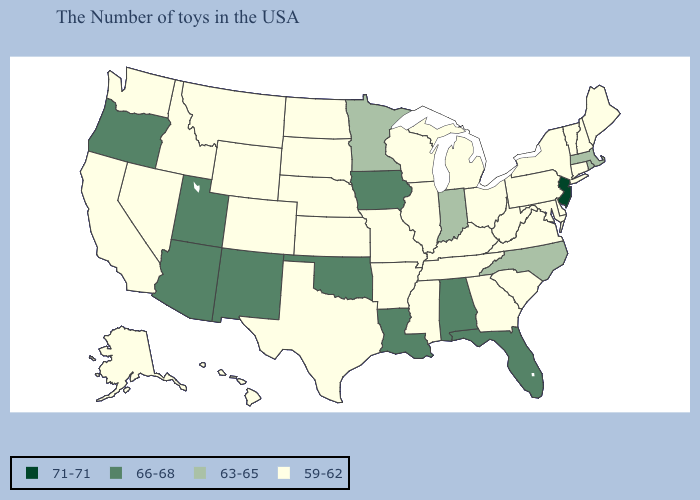What is the lowest value in the USA?
Answer briefly. 59-62. Among the states that border California , does Arizona have the lowest value?
Short answer required. No. Which states have the lowest value in the USA?
Answer briefly. Maine, New Hampshire, Vermont, Connecticut, New York, Delaware, Maryland, Pennsylvania, Virginia, South Carolina, West Virginia, Ohio, Georgia, Michigan, Kentucky, Tennessee, Wisconsin, Illinois, Mississippi, Missouri, Arkansas, Kansas, Nebraska, Texas, South Dakota, North Dakota, Wyoming, Colorado, Montana, Idaho, Nevada, California, Washington, Alaska, Hawaii. How many symbols are there in the legend?
Write a very short answer. 4. Among the states that border Florida , which have the lowest value?
Give a very brief answer. Georgia. How many symbols are there in the legend?
Give a very brief answer. 4. Does the first symbol in the legend represent the smallest category?
Concise answer only. No. Name the states that have a value in the range 63-65?
Give a very brief answer. Massachusetts, Rhode Island, North Carolina, Indiana, Minnesota. What is the value of Delaware?
Keep it brief. 59-62. Does Kansas have the lowest value in the USA?
Concise answer only. Yes. What is the value of Connecticut?
Keep it brief. 59-62. Does Kentucky have the highest value in the USA?
Write a very short answer. No. What is the value of Alaska?
Concise answer only. 59-62. Does the map have missing data?
Quick response, please. No. 